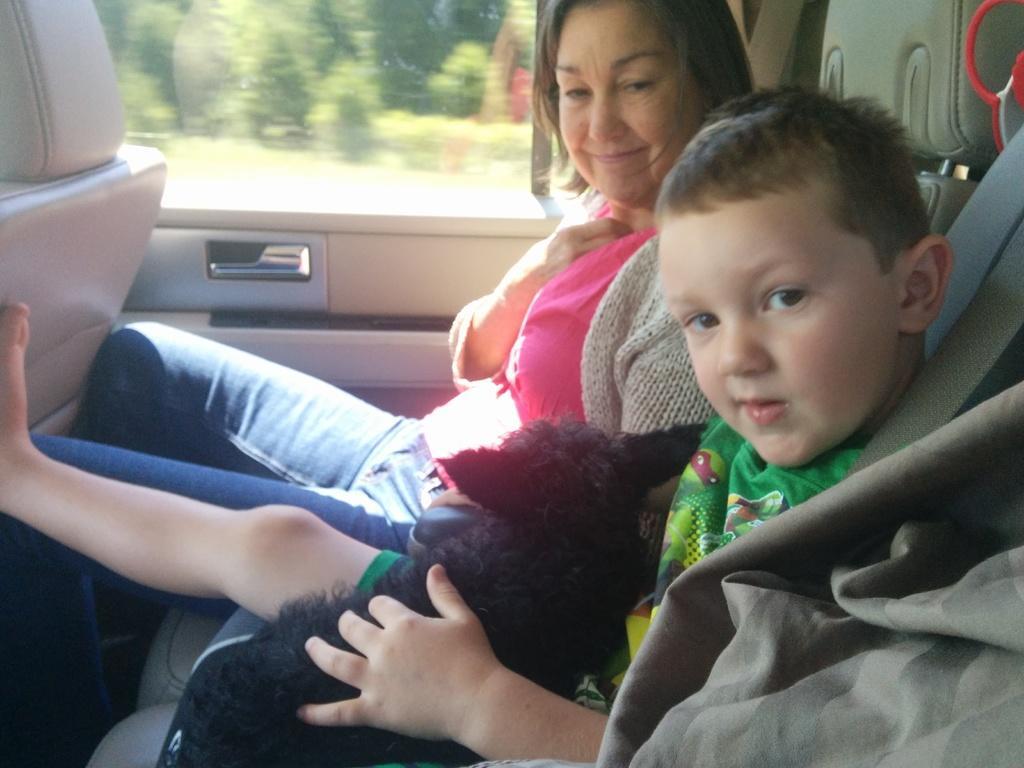How would you summarize this image in a sentence or two? In this image there are persons sitting inside the car. In the front there is a boy holding a cat. In the center there is a woman sitting and smiling. On the left side there is a seat. Outside the mirror there are trees visible. 